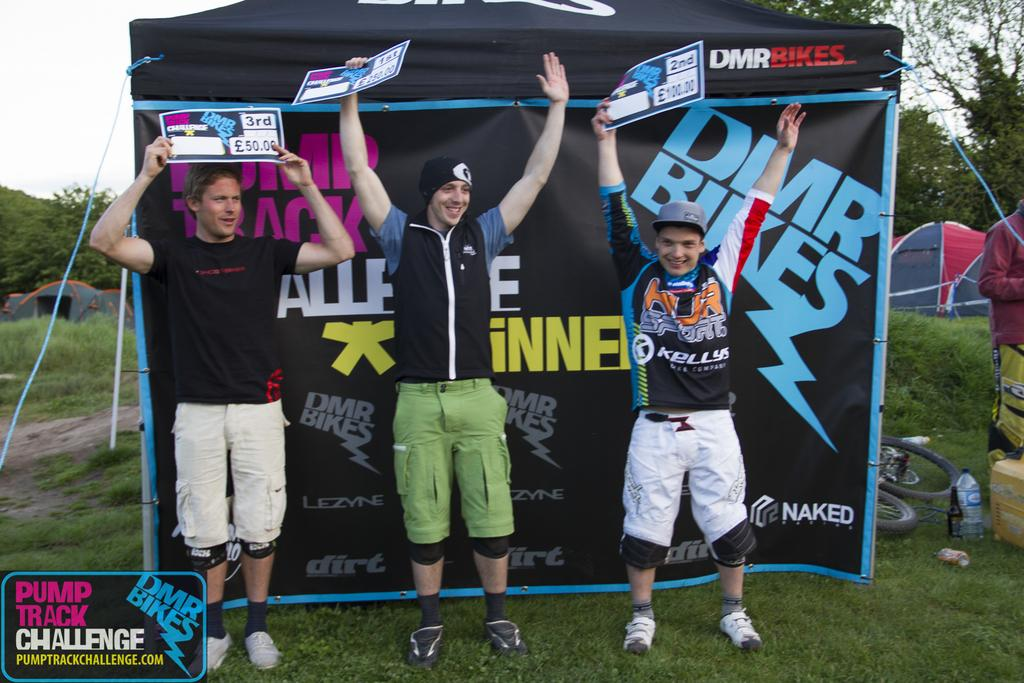Provide a one-sentence caption for the provided image. First prize at the Pump Track Challenge won 250 pounds. 